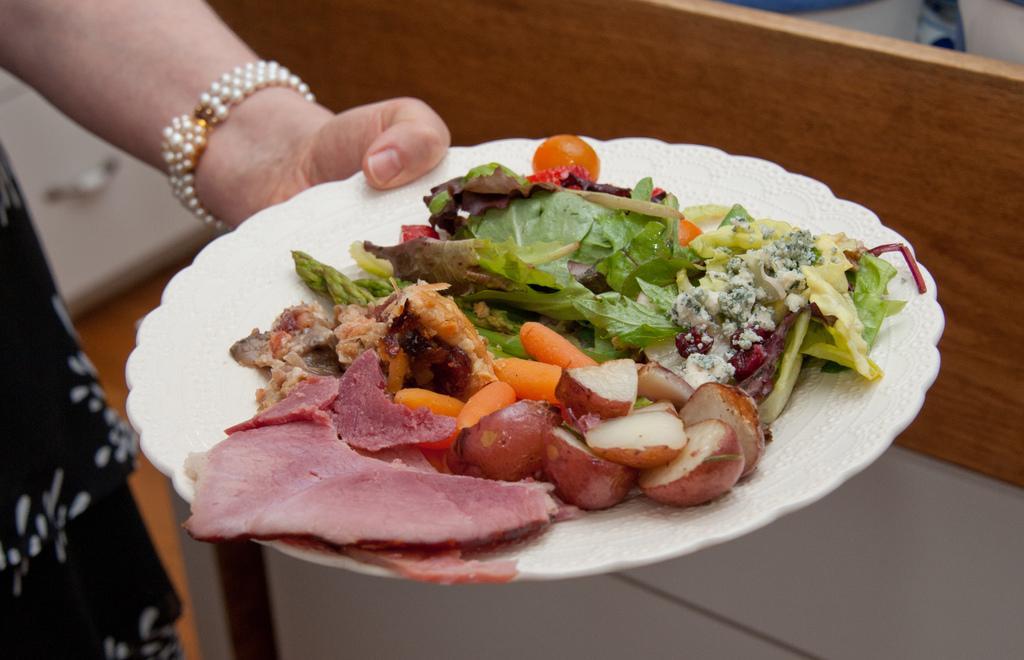Describe this image in one or two sentences. In this picture, we see a woman in the black dress is holding a plate containing the vegetables and meat. She is wearing the bracelet. Behind her, we see a white cupboard. In the background, we see a wooden wall. At the bottom, we see the floor. 